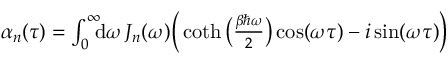Convert formula to latex. <formula><loc_0><loc_0><loc_500><loc_500>\begin{array} { r } { \alpha _ { n } ( \tau ) = \int _ { 0 } ^ { \infty } \, d \omega \, J _ { n } ( \omega ) \left ( \coth \left ( \frac { \beta \hbar { \omega } } { 2 } \right ) \cos ( \omega \tau ) - i \sin ( \omega \tau ) \right ) } \end{array}</formula> 